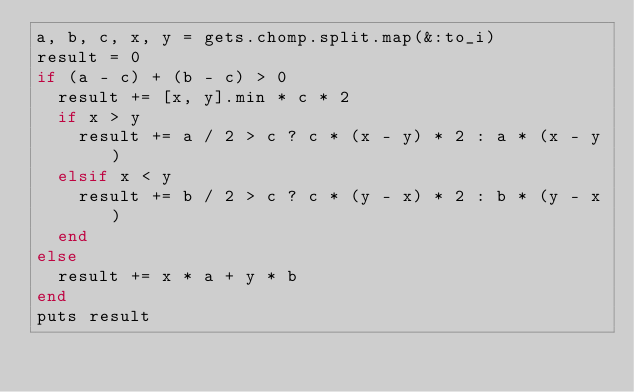Convert code to text. <code><loc_0><loc_0><loc_500><loc_500><_Ruby_>a, b, c, x, y = gets.chomp.split.map(&:to_i)
result = 0
if (a - c) + (b - c) > 0
  result += [x, y].min * c * 2
  if x > y
    result += a / 2 > c ? c * (x - y) * 2 : a * (x - y)
  elsif x < y
    result += b / 2 > c ? c * (y - x) * 2 : b * (y - x)
  end
else
  result += x * a + y * b
end
puts result
</code> 